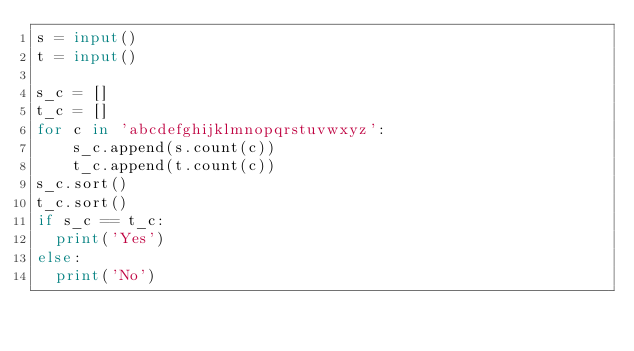Convert code to text. <code><loc_0><loc_0><loc_500><loc_500><_Python_>s = input()
t = input()
 
s_c = []
t_c = []
for c in 'abcdefghijklmnopqrstuvwxyz':
    s_c.append(s.count(c))
    t_c.append(t.count(c))
s_c.sort()
t_c.sort()
if s_c == t_c:
  print('Yes')
else:
  print('No')</code> 